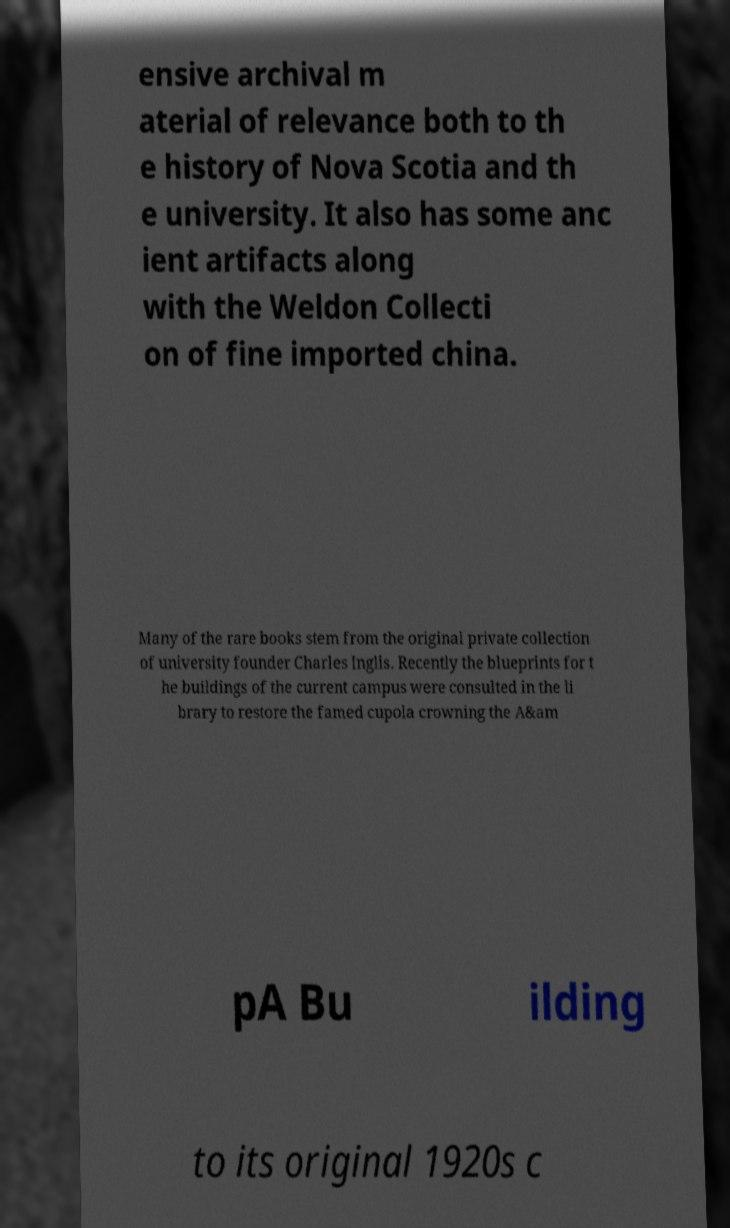Please identify and transcribe the text found in this image. ensive archival m aterial of relevance both to th e history of Nova Scotia and th e university. It also has some anc ient artifacts along with the Weldon Collecti on of fine imported china. Many of the rare books stem from the original private collection of university founder Charles Inglis. Recently the blueprints for t he buildings of the current campus were consulted in the li brary to restore the famed cupola crowning the A&am pA Bu ilding to its original 1920s c 